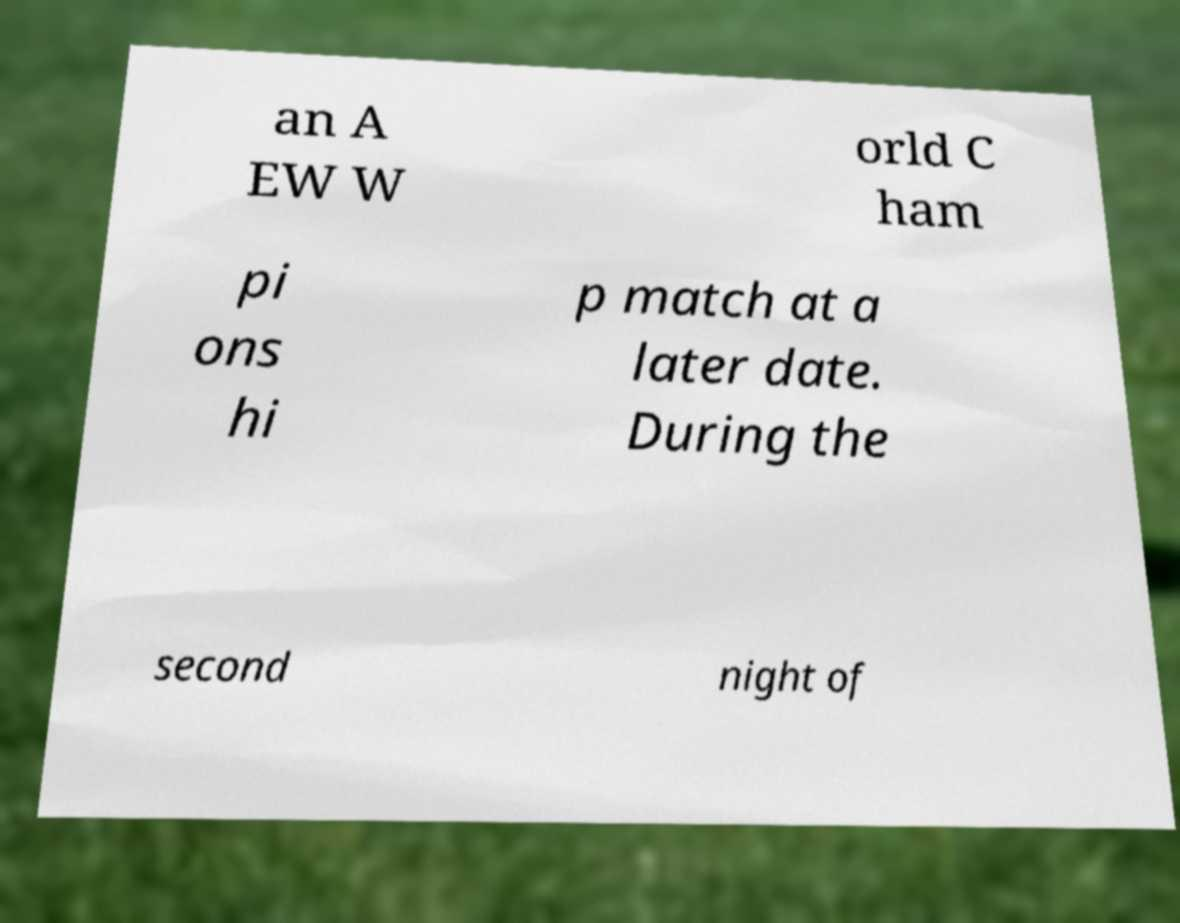Can you read and provide the text displayed in the image?This photo seems to have some interesting text. Can you extract and type it out for me? an A EW W orld C ham pi ons hi p match at a later date. During the second night of 